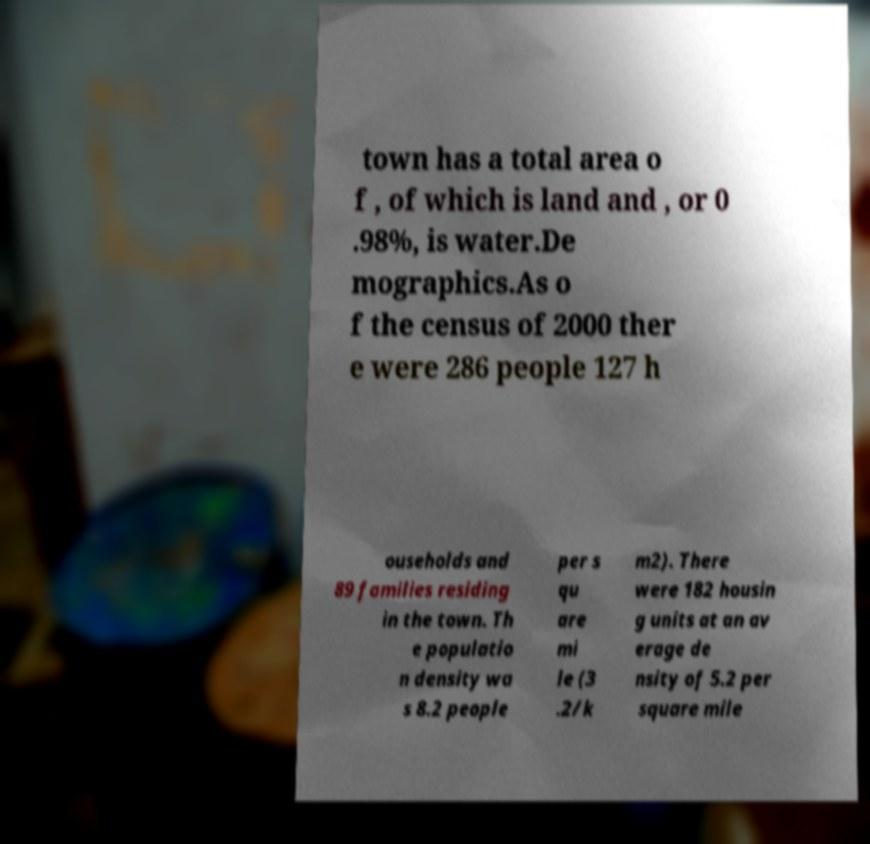Could you assist in decoding the text presented in this image and type it out clearly? town has a total area o f , of which is land and , or 0 .98%, is water.De mographics.As o f the census of 2000 ther e were 286 people 127 h ouseholds and 89 families residing in the town. Th e populatio n density wa s 8.2 people per s qu are mi le (3 .2/k m2). There were 182 housin g units at an av erage de nsity of 5.2 per square mile 